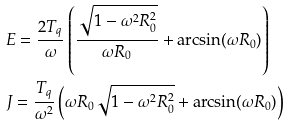Convert formula to latex. <formula><loc_0><loc_0><loc_500><loc_500>& E = \frac { 2 T _ { q } } { \omega } \left ( \frac { \sqrt { 1 - \omega ^ { 2 } R _ { 0 } ^ { 2 } } } { \omega R _ { 0 } } + \arcsin ( \omega R _ { 0 } ) \right ) \\ & J = \frac { T _ { q } } { \omega ^ { 2 } } \left ( \omega R _ { 0 } \sqrt { 1 - \omega ^ { 2 } R _ { 0 } ^ { 2 } } + \arcsin ( \omega R _ { 0 } ) \right )</formula> 